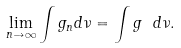<formula> <loc_0><loc_0><loc_500><loc_500>\lim _ { n \to \infty } \int g _ { n } d \nu = \int g \ d \nu .</formula> 